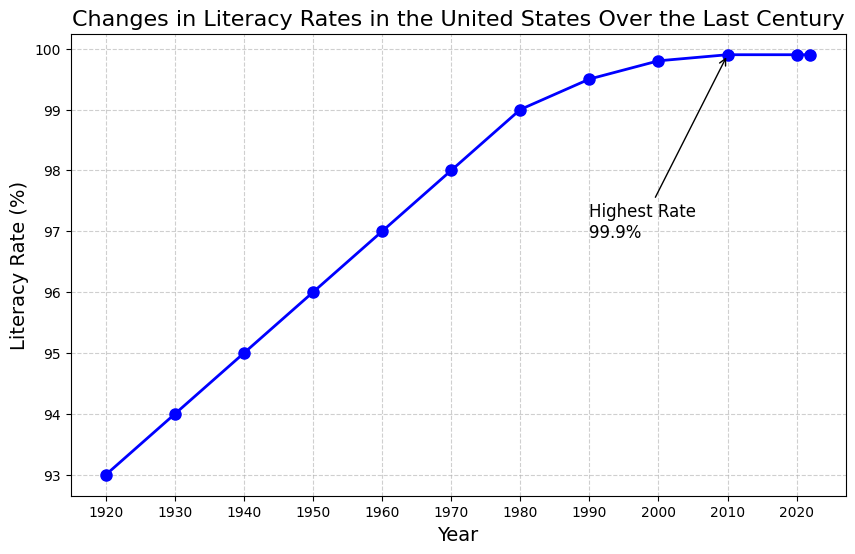What's the literacy rate in the year 1950? The plot has data points for each year showing the literacy rate. Locate the point corresponding to the year 1950 on the x-axis and read the value on the y-axis.
Answer: 96% Between which decades did the literacy rate increase the most? To determine the decade with the most significant increase, compare the difference in literacy rates for each decade. For example, between 1920 and 1930, the increase is 94.0 - 93.0 = 1.0%. Calculate this for each decade and find the maximum.
Answer: 1950-1960 Did the literacy rate ever decline at any point in the century? Review the trend line on the plot to see if at any point the literacy rate decreased, indicating a downward slope on the line.
Answer: No Where is the highest literacy rate annotated, and what is its value? There is a text annotation on the plot marking the highest literacy rate. Look for the annotation and read the value provided.
Answer: 99.9% How does the literacy rate from 1920 compare to 2020? Locate the points for 1920 and 2020 on the x-axis and read their corresponding literacy rates on the y-axis. Compare these two values directly.
Answer: 6.9% lower What is the average literacy rate over the entire period shown? To find the average, sum the literacy rates for all the years provided (93.0, 94.0, 95.0, 96.0, 97.0, 98.0, 99.0, 99.5, 99.8, 99.9, 99.9, 99.9) and divide by the number of years.
Answer: 97.8% Which decade shows the smallest increase in literacy rate? Calculate the increase for each decade by subtracting the earlier year's rate from the later year's rate. The smallest increase will be the smallest positive difference among these values.
Answer: 2010-2020 Is the trend in literacy rates more linear or does it show any significant changes in gradient? Examine the overall shape of the line on the plot. If the line has a consistent slope, it's linear; otherwise, look for segments where the slope changes significantly.
Answer: Linear By how much did the literacy rate increase between 1920 and 1980? Subtract the literacy rate for 1920 from the literacy rate for 1980 (99.0 - 93.0).
Answer: 6.0% Does the literacy rate reach 100% at any point in the last century? Check the plot to see if the y-axis value for literacy rate reaches 100% at any point between 1920 and 2022.
Answer: No 